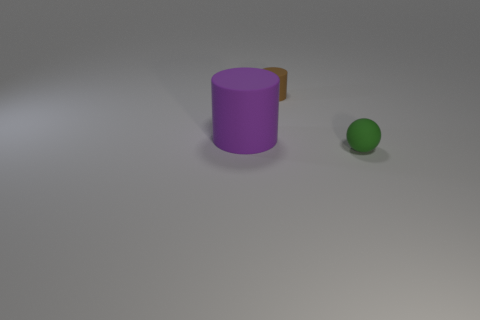Add 2 big gray objects. How many objects exist? 5 Subtract all balls. How many objects are left? 2 Subtract 0 yellow cylinders. How many objects are left? 3 Subtract all big purple cylinders. Subtract all tiny red metal things. How many objects are left? 2 Add 3 green matte spheres. How many green matte spheres are left? 4 Add 1 small rubber things. How many small rubber things exist? 3 